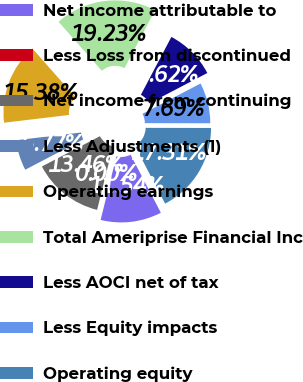<chart> <loc_0><loc_0><loc_500><loc_500><pie_chart><fcel>Net income attributable to<fcel>Less Loss from discontinued<fcel>Net income from continuing<fcel>Less Adjustments (1)<fcel>Operating earnings<fcel>Total Ameriprise Financial Inc<fcel>Less AOCI net of tax<fcel>Less Equity impacts<fcel>Operating equity<nl><fcel>11.54%<fcel>0.0%<fcel>13.46%<fcel>5.77%<fcel>15.38%<fcel>19.23%<fcel>9.62%<fcel>7.69%<fcel>17.31%<nl></chart> 